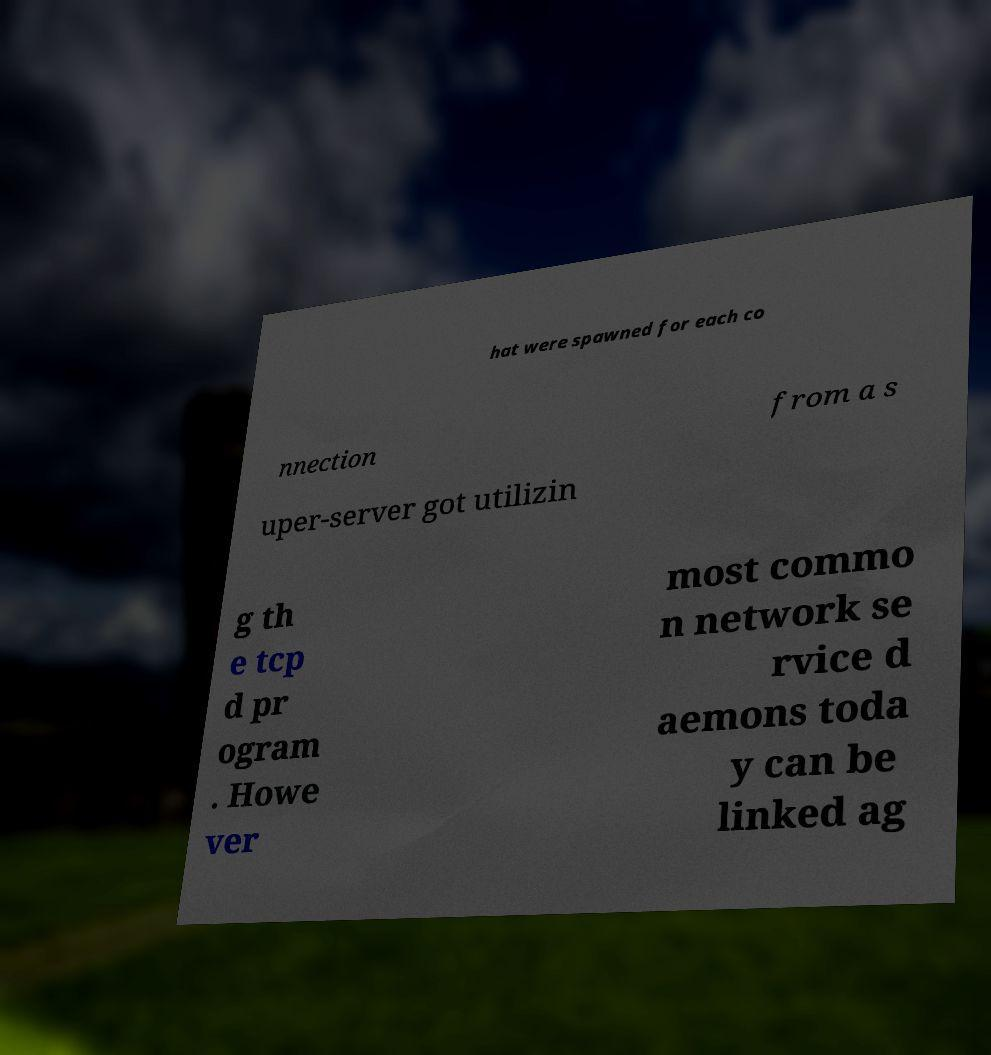What messages or text are displayed in this image? I need them in a readable, typed format. hat were spawned for each co nnection from a s uper-server got utilizin g th e tcp d pr ogram . Howe ver most commo n network se rvice d aemons toda y can be linked ag 